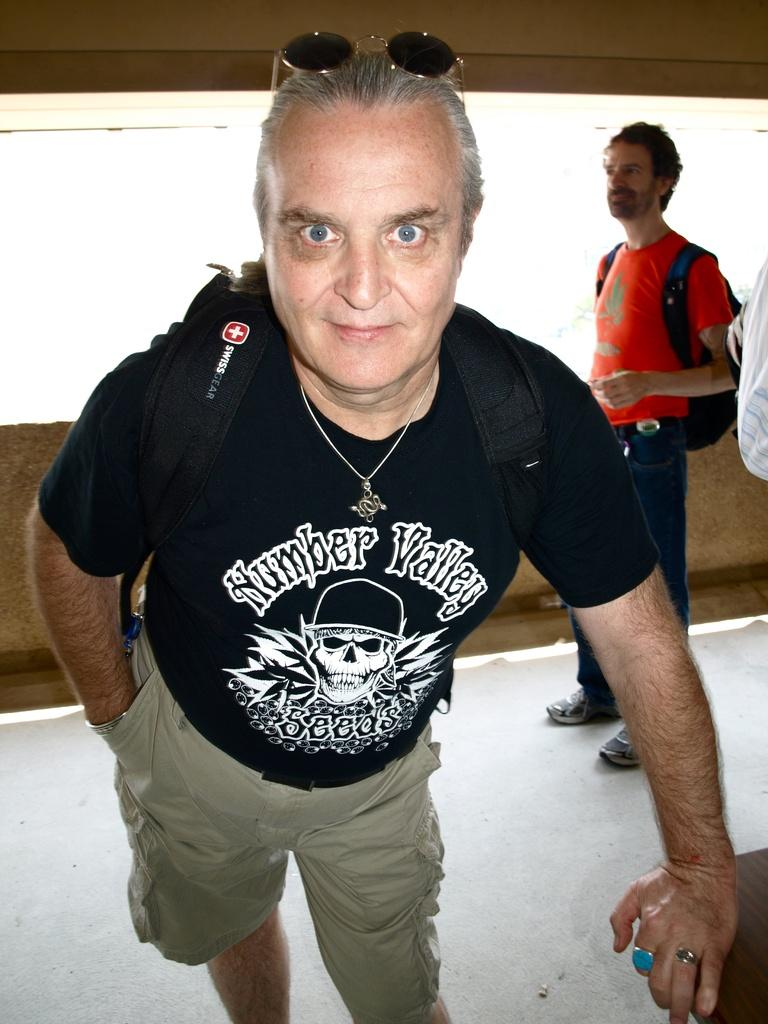<image>
Summarize the visual content of the image. An older man with glasses on his head and a black tee shirt with the words Number Valley written on it. 